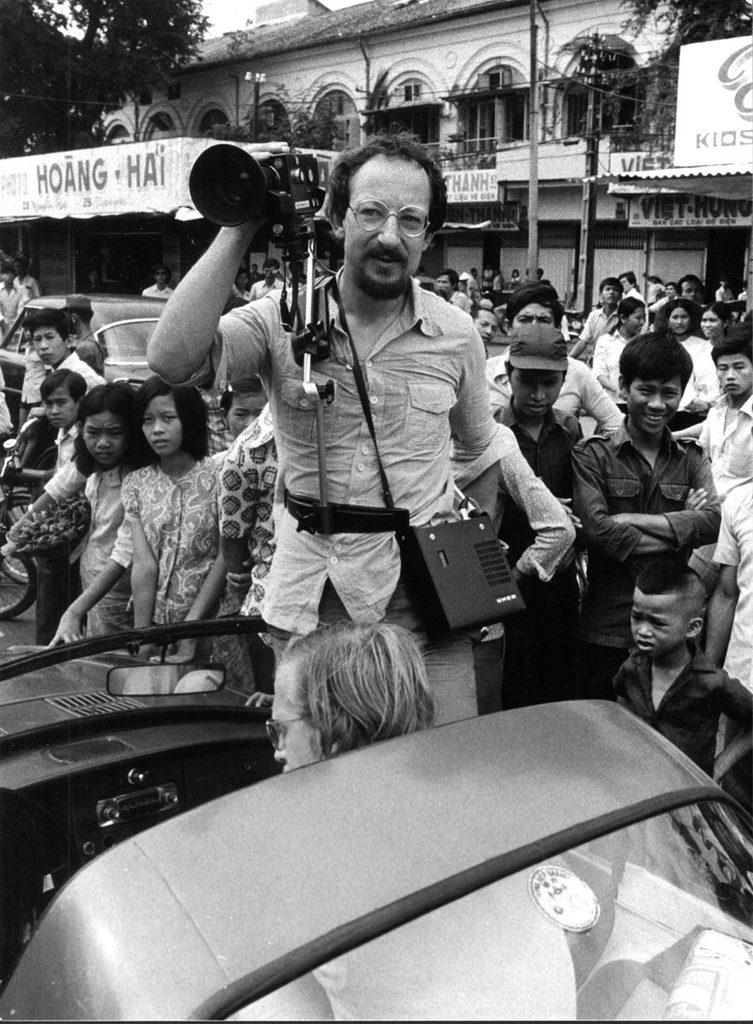What is the person in the image doing? The person is standing on a vehicle and holding a camera. What can be seen in the background of the image? There are buildings, poles, name boards, trees, and the sky visible in the background. Are there any other people in the image? Yes, there is a group of people standing in the background. What type of polish is being applied to the beef in the image? There is no beef or polish present in the image; it features a person standing on a vehicle with a camera and a background with various objects and structures. 